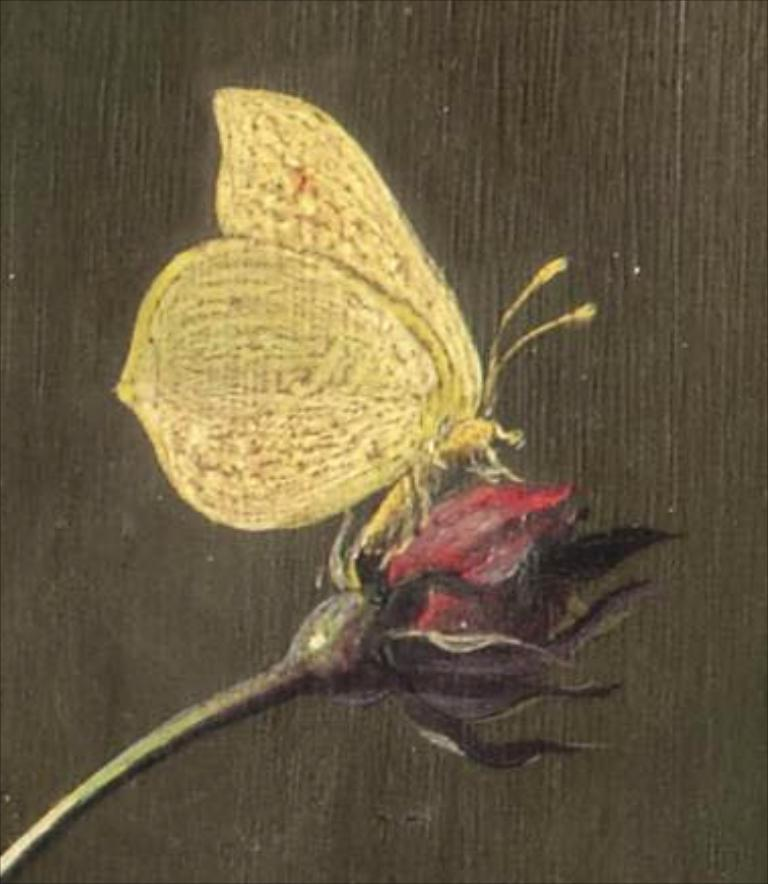What type of insect can be seen in the image? There is a butterfly in the image. What is the butterfly sitting on in the image? There is a flower on the surface in the image. What type of wax can be seen dripping from the clouds in the image? There are no clouds or wax present in the image; it features a butterfly on a flower. 